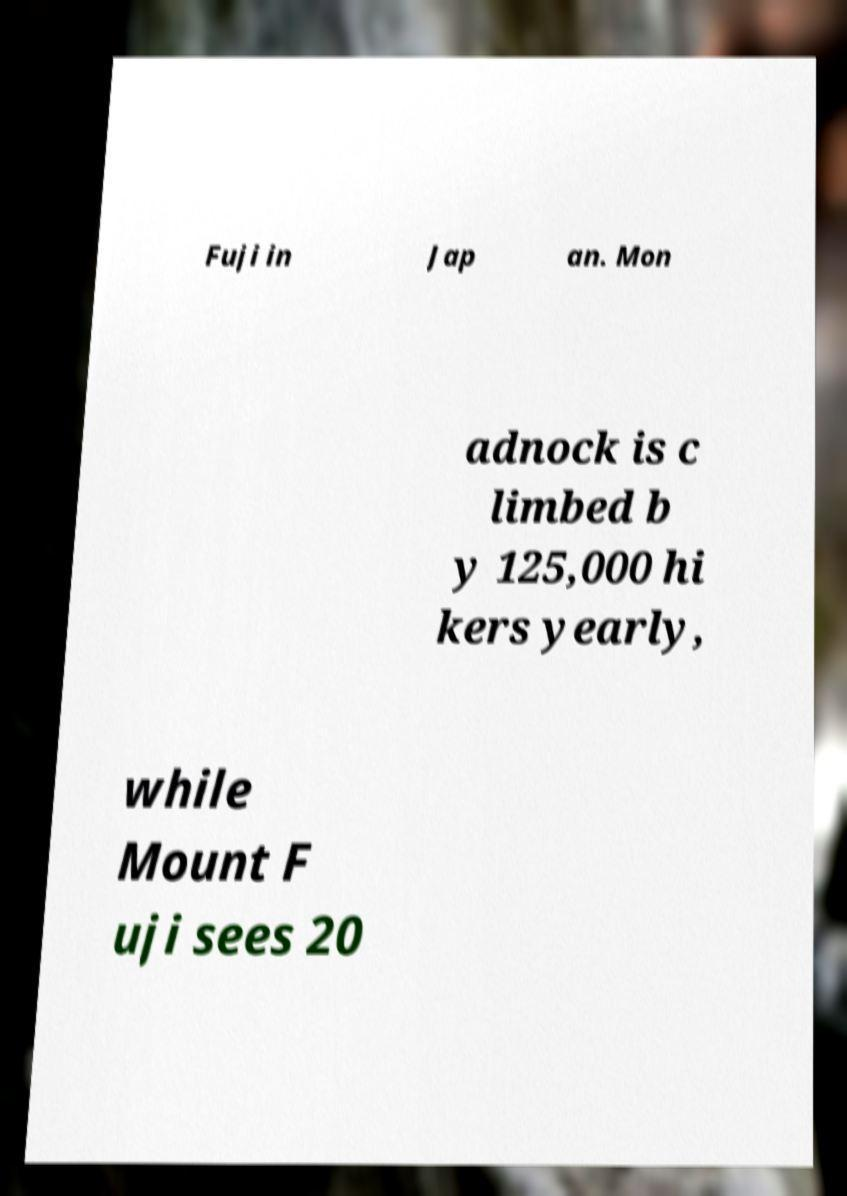What messages or text are displayed in this image? I need them in a readable, typed format. Fuji in Jap an. Mon adnock is c limbed b y 125,000 hi kers yearly, while Mount F uji sees 20 